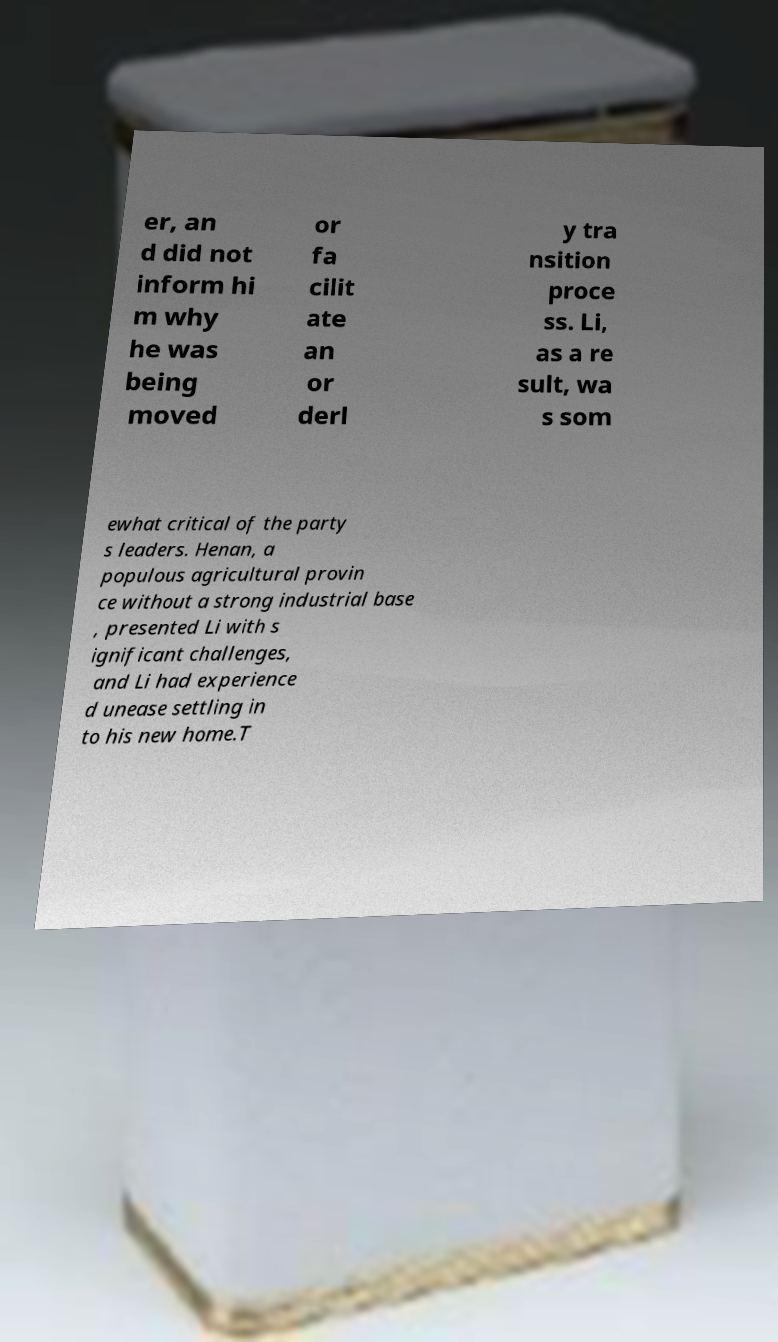Please read and relay the text visible in this image. What does it say? er, an d did not inform hi m why he was being moved or fa cilit ate an or derl y tra nsition proce ss. Li, as a re sult, wa s som ewhat critical of the party s leaders. Henan, a populous agricultural provin ce without a strong industrial base , presented Li with s ignificant challenges, and Li had experience d unease settling in to his new home.T 